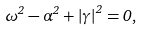<formula> <loc_0><loc_0><loc_500><loc_500>\omega ^ { 2 } - \alpha ^ { 2 } + \left | \gamma \right | ^ { 2 } = 0 ,</formula> 